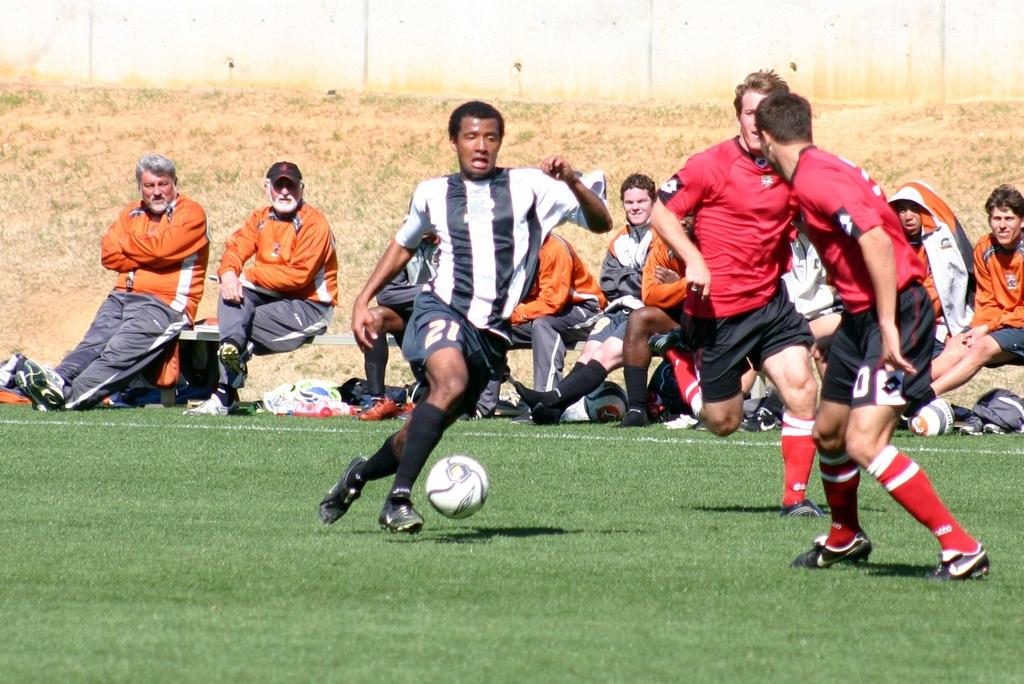Where was the image taken? The image was taken in a ground. What are the people in the image doing? There are persons sitting on benches, and there are 3 persons in the middle, playing. What object is being used in the playing area? There is a ball in the middle of the playing area. What type of regret can be seen on the faces of the persons sitting on the benches? There is no indication of regret on the faces of the persons sitting on the benches in the image. What show is being performed in the middle of the playing area? There is no show being performed in the image; it features people playing with a ball. 